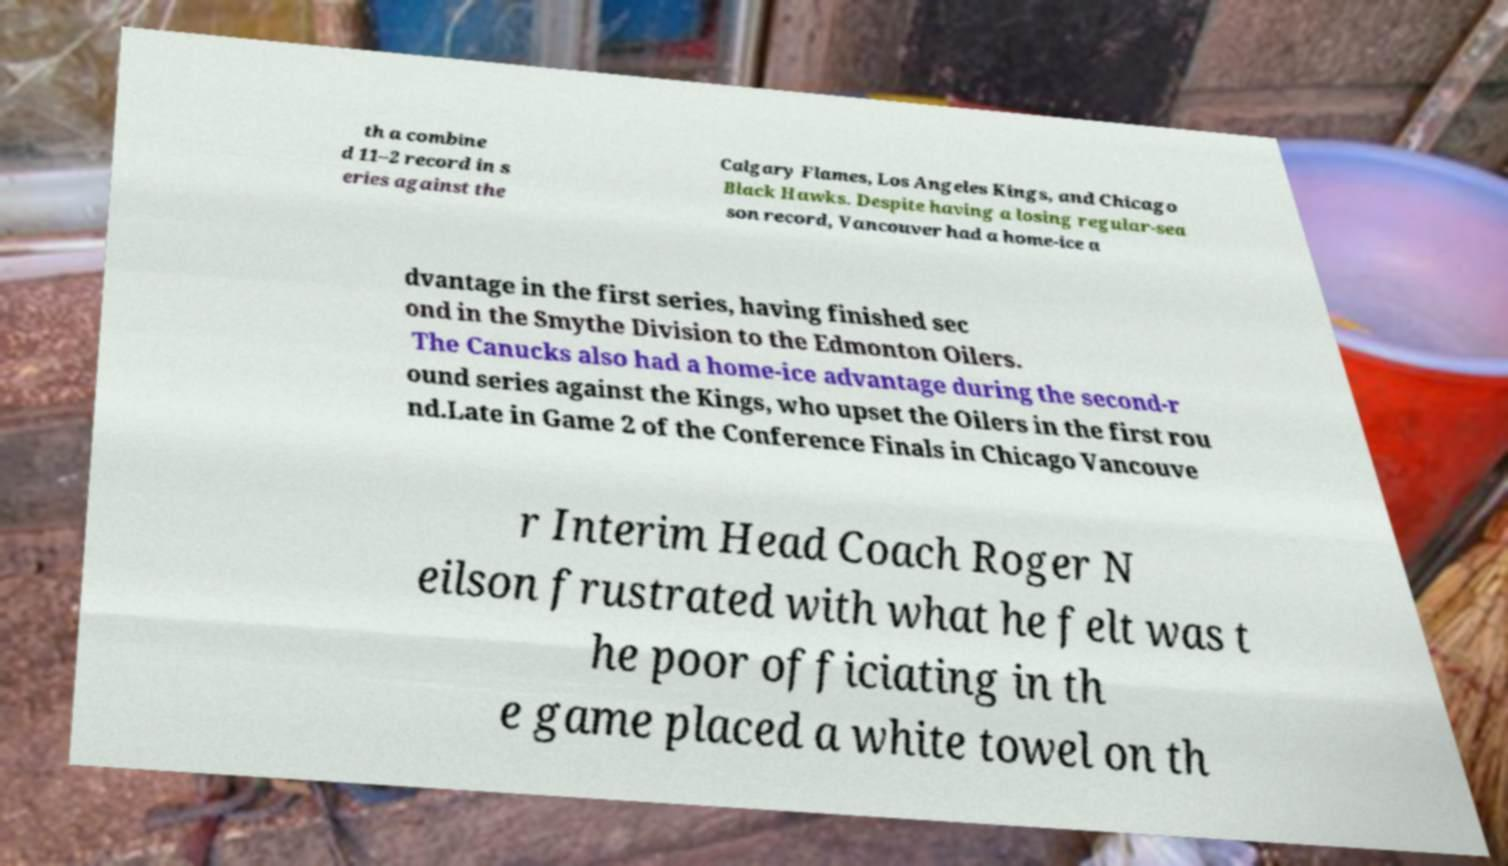I need the written content from this picture converted into text. Can you do that? th a combine d 11–2 record in s eries against the Calgary Flames, Los Angeles Kings, and Chicago Black Hawks. Despite having a losing regular-sea son record, Vancouver had a home-ice a dvantage in the first series, having finished sec ond in the Smythe Division to the Edmonton Oilers. The Canucks also had a home-ice advantage during the second-r ound series against the Kings, who upset the Oilers in the first rou nd.Late in Game 2 of the Conference Finals in Chicago Vancouve r Interim Head Coach Roger N eilson frustrated with what he felt was t he poor officiating in th e game placed a white towel on th 